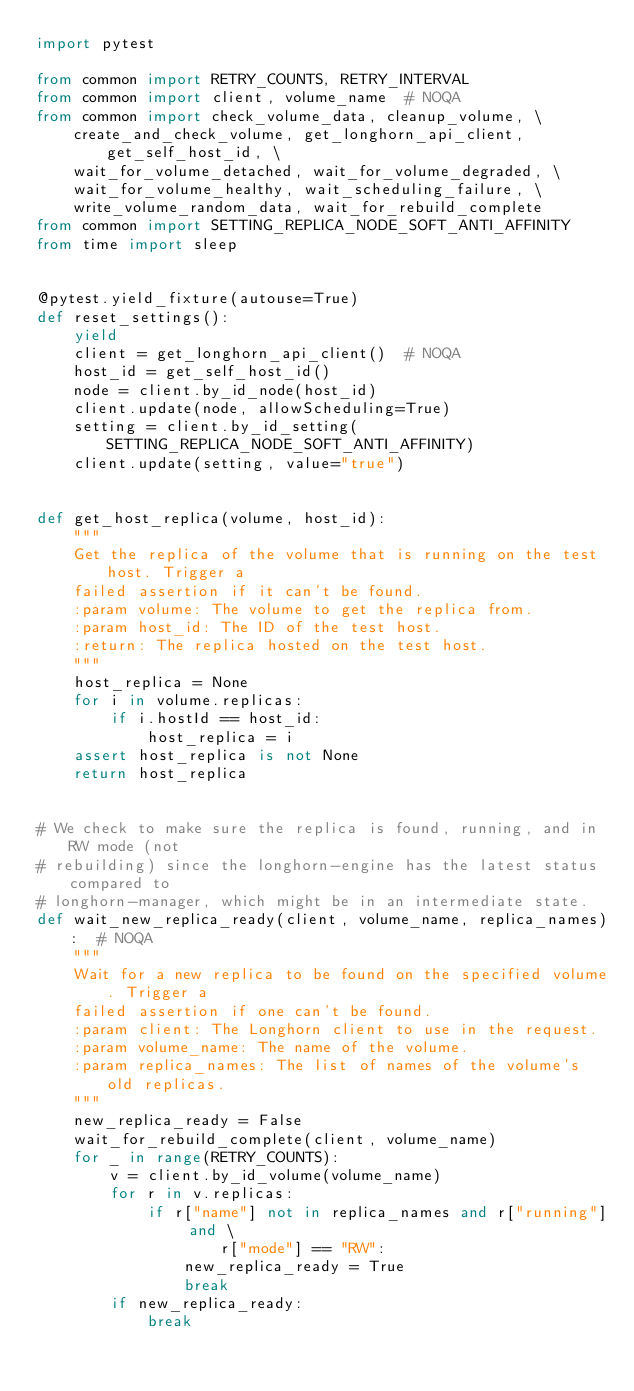<code> <loc_0><loc_0><loc_500><loc_500><_Python_>import pytest

from common import RETRY_COUNTS, RETRY_INTERVAL
from common import client, volume_name  # NOQA
from common import check_volume_data, cleanup_volume, \
    create_and_check_volume, get_longhorn_api_client, get_self_host_id, \
    wait_for_volume_detached, wait_for_volume_degraded, \
    wait_for_volume_healthy, wait_scheduling_failure, \
    write_volume_random_data, wait_for_rebuild_complete
from common import SETTING_REPLICA_NODE_SOFT_ANTI_AFFINITY
from time import sleep


@pytest.yield_fixture(autouse=True)
def reset_settings():
    yield
    client = get_longhorn_api_client()  # NOQA
    host_id = get_self_host_id()
    node = client.by_id_node(host_id)
    client.update(node, allowScheduling=True)
    setting = client.by_id_setting(SETTING_REPLICA_NODE_SOFT_ANTI_AFFINITY)
    client.update(setting, value="true")


def get_host_replica(volume, host_id):
    """
    Get the replica of the volume that is running on the test host. Trigger a
    failed assertion if it can't be found.
    :param volume: The volume to get the replica from.
    :param host_id: The ID of the test host.
    :return: The replica hosted on the test host.
    """
    host_replica = None
    for i in volume.replicas:
        if i.hostId == host_id:
            host_replica = i
    assert host_replica is not None
    return host_replica


# We check to make sure the replica is found, running, and in RW mode (not
# rebuilding) since the longhorn-engine has the latest status compared to
# longhorn-manager, which might be in an intermediate state.
def wait_new_replica_ready(client, volume_name, replica_names):  # NOQA
    """
    Wait for a new replica to be found on the specified volume. Trigger a
    failed assertion if one can't be found.
    :param client: The Longhorn client to use in the request.
    :param volume_name: The name of the volume.
    :param replica_names: The list of names of the volume's old replicas.
    """
    new_replica_ready = False
    wait_for_rebuild_complete(client, volume_name)
    for _ in range(RETRY_COUNTS):
        v = client.by_id_volume(volume_name)
        for r in v.replicas:
            if r["name"] not in replica_names and r["running"] and \
                    r["mode"] == "RW":
                new_replica_ready = True
                break
        if new_replica_ready:
            break</code> 